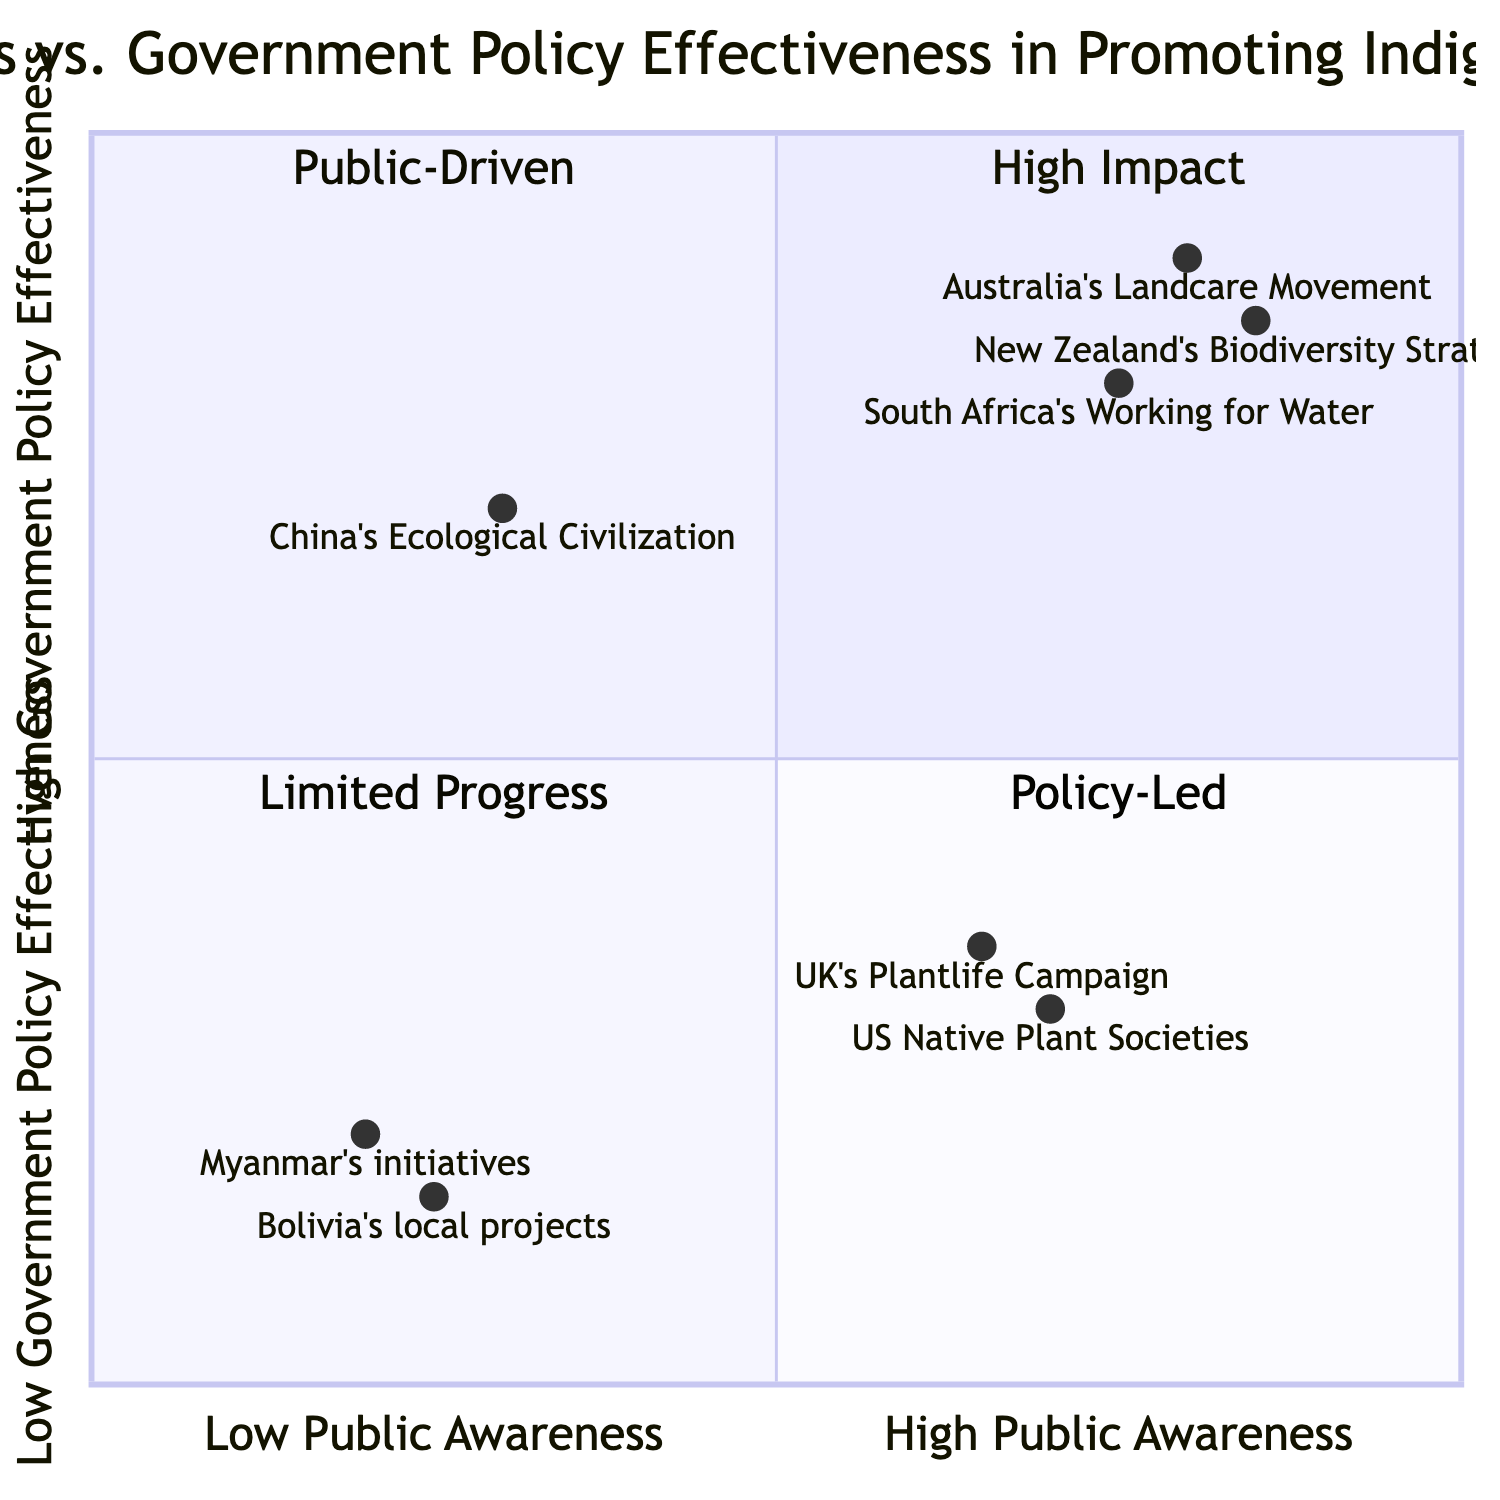What is the impact of South Africa's Working for Water program? The impact for South Africa's Working for Water program, found in the "High Public Awareness, High Government Policy Effectiveness" quadrant, states that it leads to a substantial increase in the use of indigenous plants in ecological restoration projects.
Answer: Substantial increase in use of indigenous plants How many examples are listed in the "Low Public Awareness, Low Government Policy Effectiveness" quadrant? The quadrant contains examples of Myanmar's indigenous plant initiatives and Bolivia's local restoration projects. Counting these, there are two examples.
Answer: 2 Which quadrant contains China's Ecological Civilization policies? China's Ecological Civilization policies are classified in the "Low Public Awareness, High Government Policy Effectiveness" quadrant.
Answer: Low Public Awareness, High Government Policy Effectiveness What is a significant result from Australia’s Landcare Movement? The details for Australia’s Landcare Movement indicate that there is a substantial increase in the use of indigenous plants in ecological restoration projects, which translates into significant ecological and social benefits.
Answer: Significant ecological and social benefits Which initiatives show high public awareness but low government policy effectiveness? Looking at the quadrants, the examples in the "High Public Awareness, Low Government Policy Effectiveness" quadrant include US Native Plant Societies and the UK’s Plantlife Campaign.
Answer: US Native Plant Societies, UK’s Plantlife Campaign What could be inferred about the public engagement in the "Low Public Awareness, High Government Policy Effectiveness" quadrant? In this quadrant, there is progress in policy implementations; however, the absence of public engagement suggests that despite effective policies, community-level initiatives struggle due to low awareness.
Answer: Lack of public engagement 